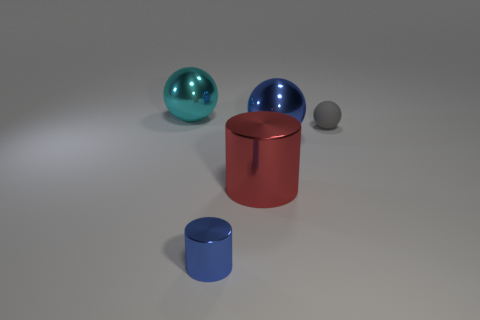Add 2 big cylinders. How many objects exist? 7 Subtract all cyan metallic spheres. How many spheres are left? 2 Subtract 2 balls. How many balls are left? 1 Subtract all gray spheres. How many yellow cylinders are left? 0 Subtract all tiny yellow spheres. Subtract all small gray objects. How many objects are left? 4 Add 2 matte things. How many matte things are left? 3 Add 5 small spheres. How many small spheres exist? 6 Subtract all red cylinders. How many cylinders are left? 1 Subtract 0 yellow spheres. How many objects are left? 5 Subtract all cylinders. How many objects are left? 3 